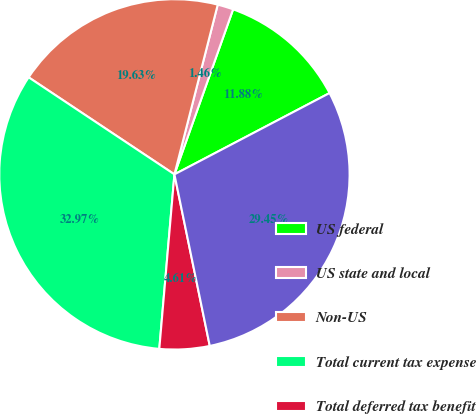Convert chart to OTSL. <chart><loc_0><loc_0><loc_500><loc_500><pie_chart><fcel>US federal<fcel>US state and local<fcel>Non-US<fcel>Total current tax expense<fcel>Total deferred tax benefit<fcel>Total<nl><fcel>11.88%<fcel>1.46%<fcel>19.63%<fcel>32.97%<fcel>4.61%<fcel>29.45%<nl></chart> 